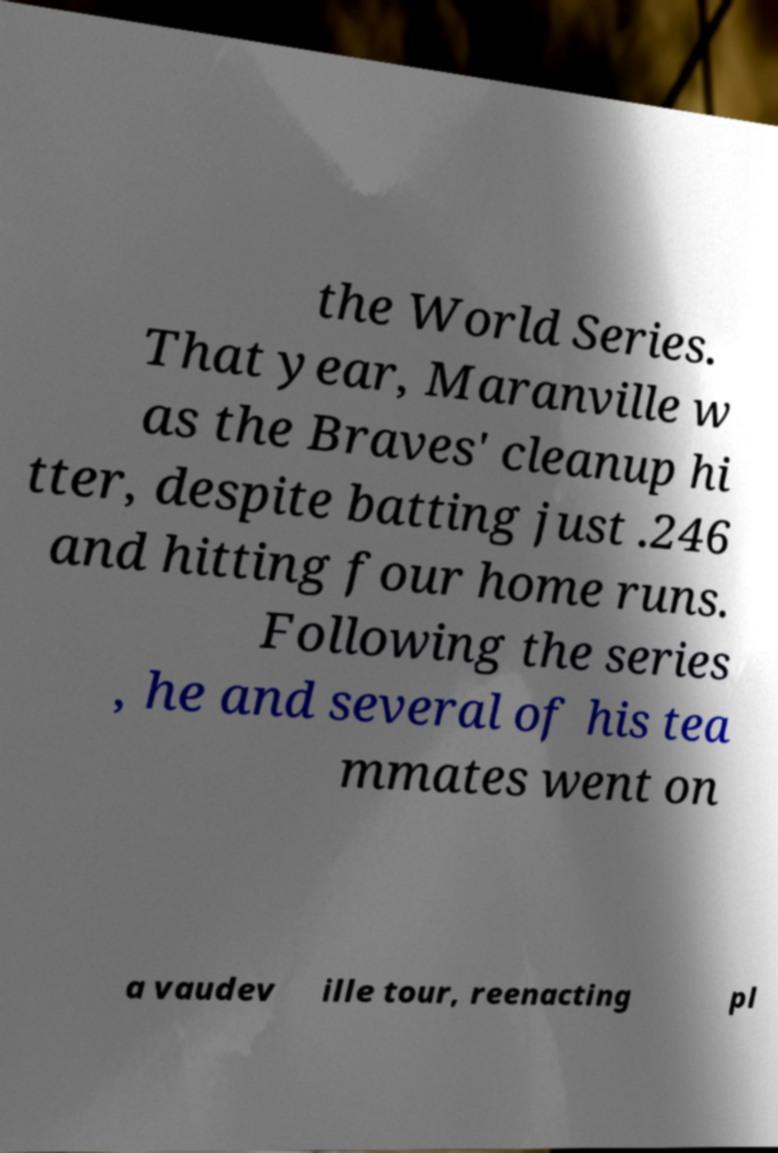Can you accurately transcribe the text from the provided image for me? the World Series. That year, Maranville w as the Braves' cleanup hi tter, despite batting just .246 and hitting four home runs. Following the series , he and several of his tea mmates went on a vaudev ille tour, reenacting pl 